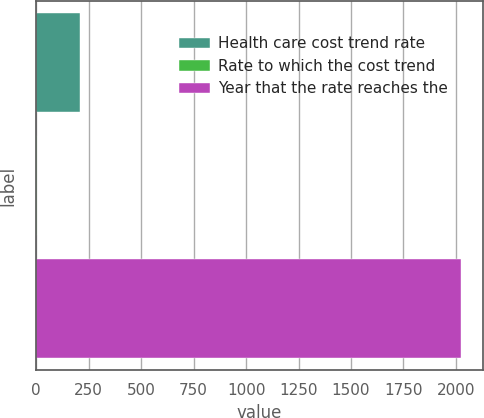Convert chart. <chart><loc_0><loc_0><loc_500><loc_500><bar_chart><fcel>Health care cost trend rate<fcel>Rate to which the cost trend<fcel>Year that the rate reaches the<nl><fcel>207.1<fcel>5<fcel>2026<nl></chart> 